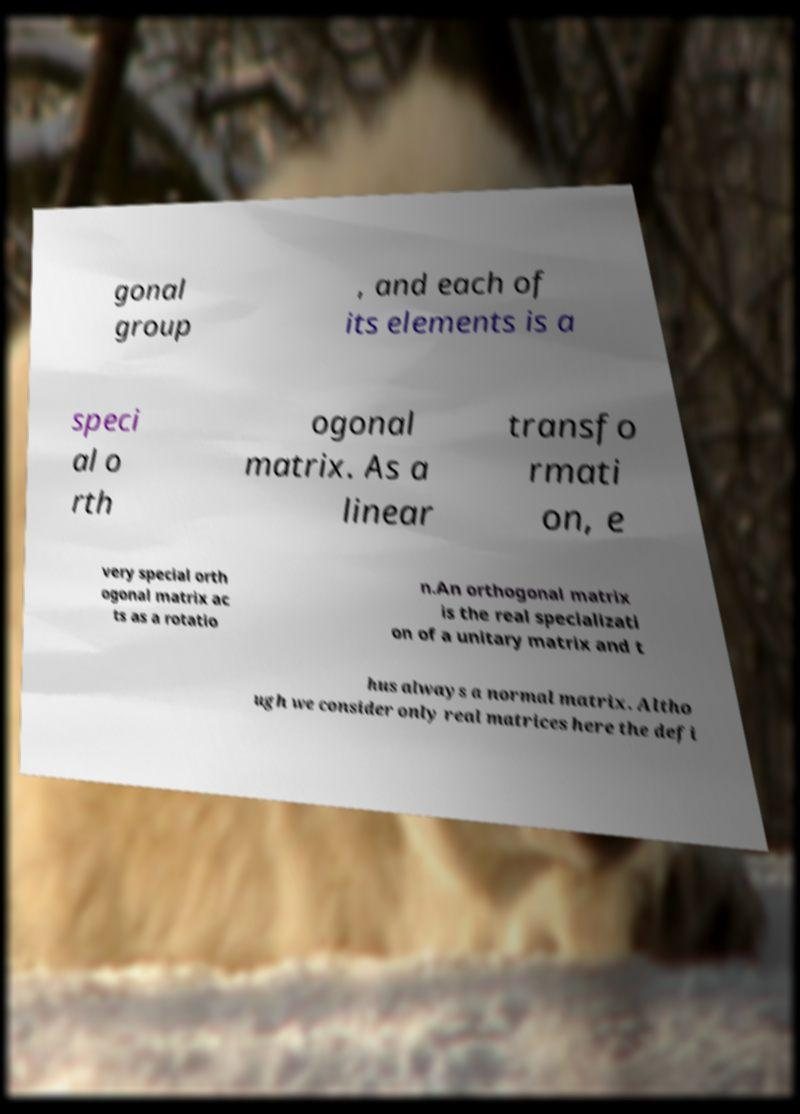Please identify and transcribe the text found in this image. gonal group , and each of its elements is a speci al o rth ogonal matrix. As a linear transfo rmati on, e very special orth ogonal matrix ac ts as a rotatio n.An orthogonal matrix is the real specializati on of a unitary matrix and t hus always a normal matrix. Altho ugh we consider only real matrices here the defi 